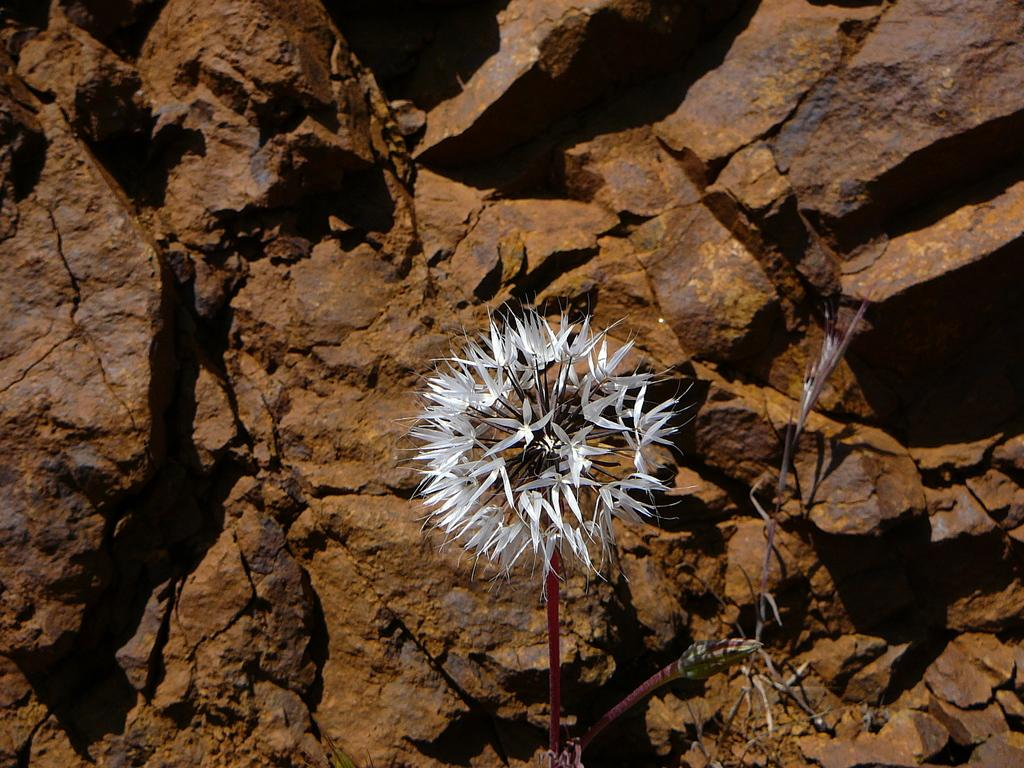What type of flower is in the image? There is a white flower in the image. What else can be seen in the image besides the flower? Rocks are visible in the image. Where is the coal mine located in the image? There is no coal mine present in the image. What type of window can be seen in the image? There is no window present in the image. 